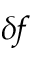Convert formula to latex. <formula><loc_0><loc_0><loc_500><loc_500>\delta \, f</formula> 